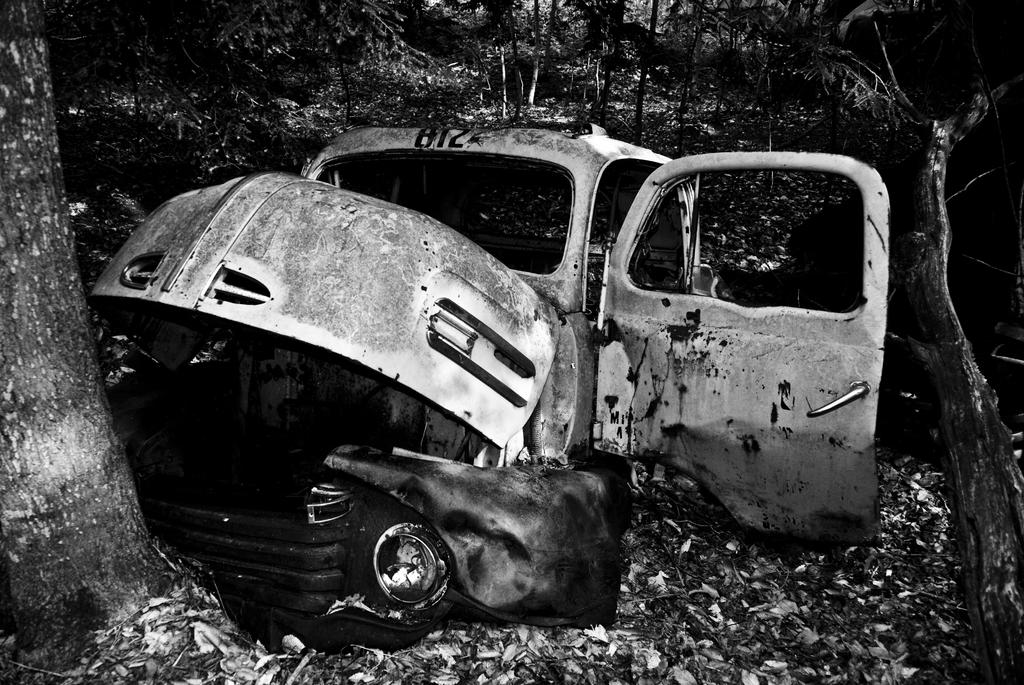What is the color scheme of the image? The image is black and white. What is the main subject in the center of the image? There is a vehicle in the center of the image. What can be seen in the background of the image? There are trees and dry leaves in the background of the image. Are there any other objects visible in the background? Yes, there are a few other objects in the background of the image. Can you see any tomatoes growing on the trees in the background? There are no tomatoes visible in the image, as it is a black and white image and tomatoes are not present in the scene. 